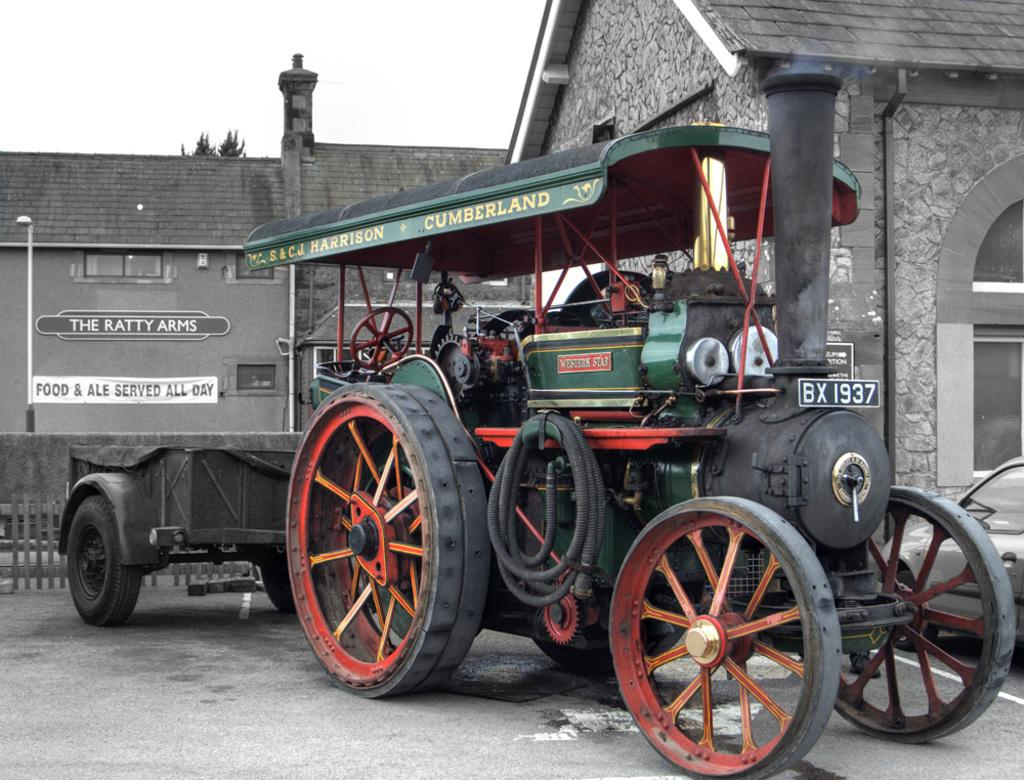What is the main subject in the foreground of the image? There is a vehicle in the foreground of the image. Where is the vehicle located? The vehicle is on the road. What can be seen in the background of the image? There are buildings, a fence, and the sky visible in the background of the image. Can you describe the time of day when the image was taken? The image was taken during the day. What type of force is being applied to the cup in the image? There is no cup present in the image, so no force is being applied to a cup. 